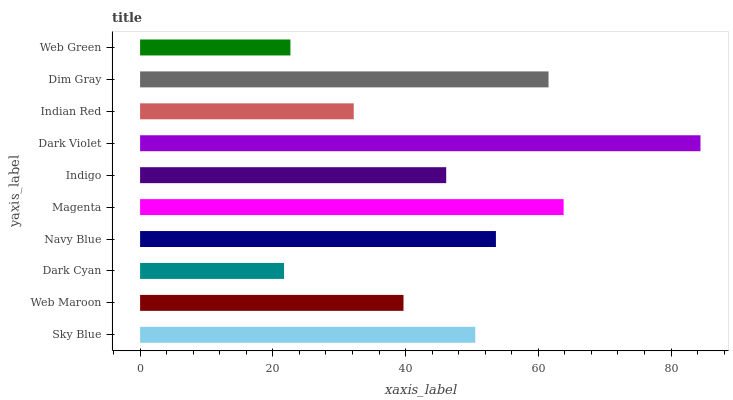Is Dark Cyan the minimum?
Answer yes or no. Yes. Is Dark Violet the maximum?
Answer yes or no. Yes. Is Web Maroon the minimum?
Answer yes or no. No. Is Web Maroon the maximum?
Answer yes or no. No. Is Sky Blue greater than Web Maroon?
Answer yes or no. Yes. Is Web Maroon less than Sky Blue?
Answer yes or no. Yes. Is Web Maroon greater than Sky Blue?
Answer yes or no. No. Is Sky Blue less than Web Maroon?
Answer yes or no. No. Is Sky Blue the high median?
Answer yes or no. Yes. Is Indigo the low median?
Answer yes or no. Yes. Is Dim Gray the high median?
Answer yes or no. No. Is Dim Gray the low median?
Answer yes or no. No. 